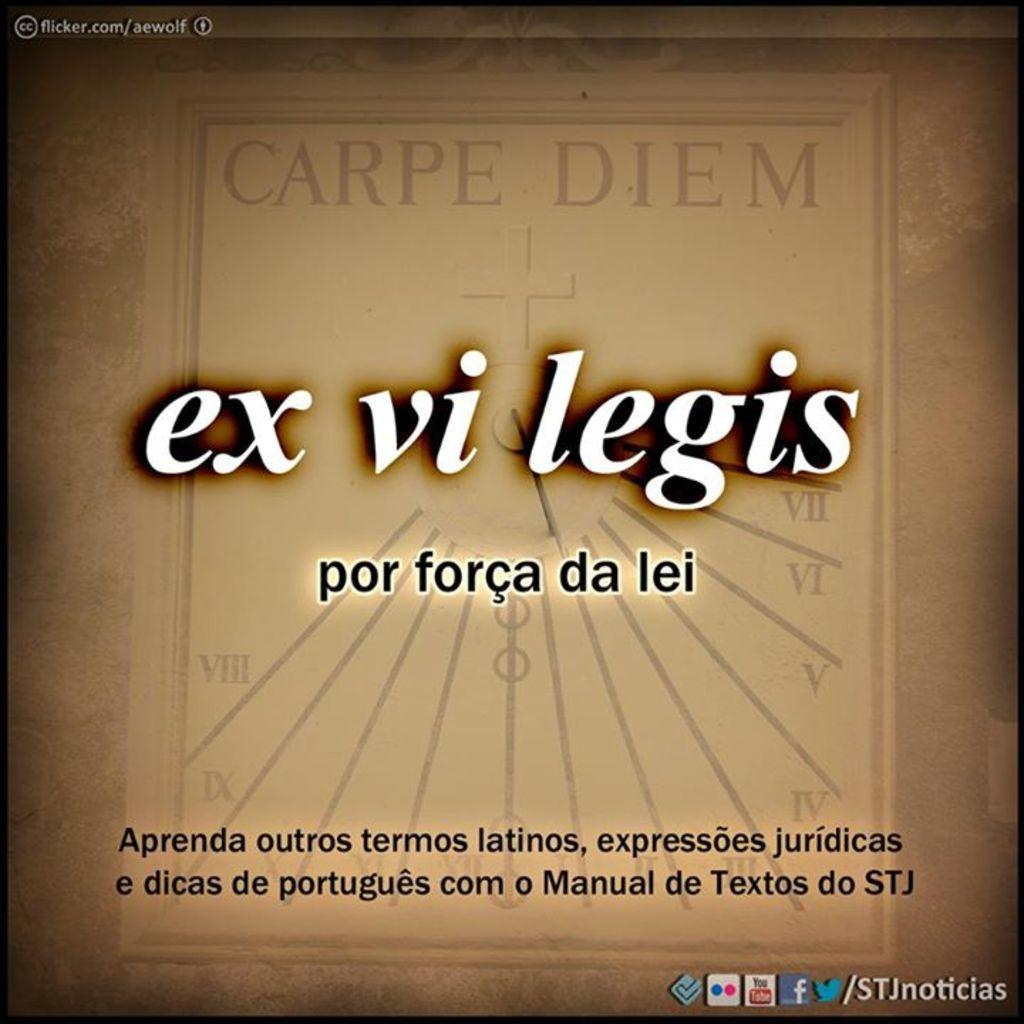What is the link on the top left?
Give a very brief answer. Flicker.com/aewolf. Do they have a facebook?
Your answer should be very brief. Yes. 